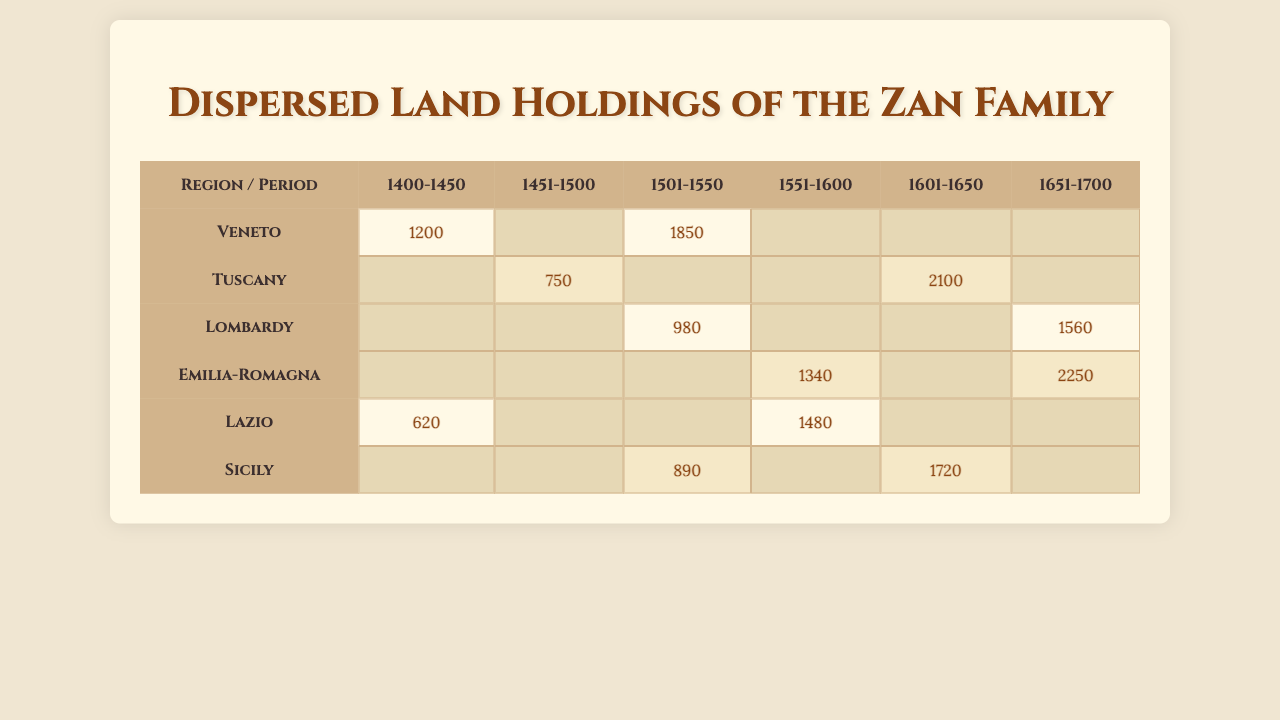What region had the highest land holdings in the period 1601-1650? Looking at the table, in the period 1601-1650, the land holdings are as follows: Tuscany has 2100 hectares and Emilia-Romagna has 2250 hectares. Since 2250 is greater than 2100, the region with the highest holdings is Emilia-Romagna.
Answer: Emilia-Romagna How many hectares of land did the Zan family own in Tuscany during the period 1451-1500? Referring to the table, Tuscany's land holdings during 1451-1500 are listed as 750 hectares. Therefore, the answer is directly found in the data.
Answer: 750 Which period did the Zan family have the least amount of land holdings in Lazio? In the table, examining Lazio's land holdings, during the period 1400-1450, the family had 620 hectares, and during 1551-1600, they had 1480 hectares. Thus, the least amount held was 620 hectares.
Answer: 620 Calculate the total land holdings of the Zan family in Lombardy across all periods listed. The periods for Lombardy show land holdings of 980 hectares for 1501-1550 and 1560 hectares for 1651-1700. Summing these amounts gives 980 + 1560 = 2540 hectares.
Answer: 2540 Is it true that the Zan family has holdings in all the regions for each of the time periods listed? Reviewing the table shows that certain regions do not have holdings in specific time periods. For example, there are no recorded holdings for Emilia-Romagna in the periods 1400-1450 and 1451-1500, confirming that they do not have holdings in every region for each time period.
Answer: No In which region did the Zan family increase their land holdings the most from 1501-1550 to 1601-1650? Looking closely at the holdings, they owned 890 hectares in Sicily for 1501-1550 and 1720 hectares for 1601-1650, which is an increase of 830 hectares. Comparing this with Tuscany, which increased from 750 hectares to 2100 hectares (an increase of 1350 hectares), shows Tuscany saw the most significant increase from these periods.
Answer: Tuscany What was the average land holding of the Zan family in Emilia-Romagna for the periods it has holdings? Emilia-Romagna has values of 1340 hectares for 1551-1600 and 2250 hectares for 1651-1700. The average is calculated as (1340 + 2250) / 2 = 1795 hectares.
Answer: 1795 Did the Zan family own more land in Veneto or Tuscany for the period 1601-1650? From the table, Tuscan holdings in 1601-1650 are 2100 hectares, while Veneto has no reported holdings for this period (hence 0 hectares). Since 2100 is greater than 0, they owned more land in Tuscany.
Answer: Tuscany What is the total land area held by the Zan family in the period 1501-1550 across all regions? Summing the land holdings for the period 1501-1550: Veneto (1850) + Lombardy (980) + Sicily (890) = 3720 hectares.
Answer: 3720 Which time period shows the highest total land holdings across all regions? By evaluating each period, we find the totals as follows: 1400-1450 = (1200 + 620) = 1820 hectares, 1451-1500 = 750 hectares, 1501-1550 = (1850 + 980 + 890) = 3720 hectares, 1551-1600 = (1340 + 1480) = 2820 hectares, 1601-1650 = (2100 + 1720) = 3820 hectares, 1651-1700 = (1560 + 2250) = 3810 hectares. The highest total is from 1601-1650 with 3820 hectares.
Answer: 1601-1650 